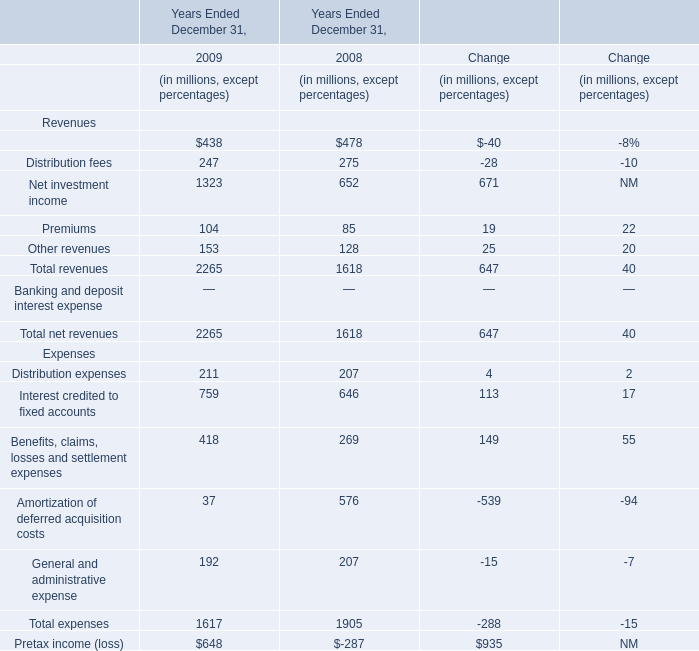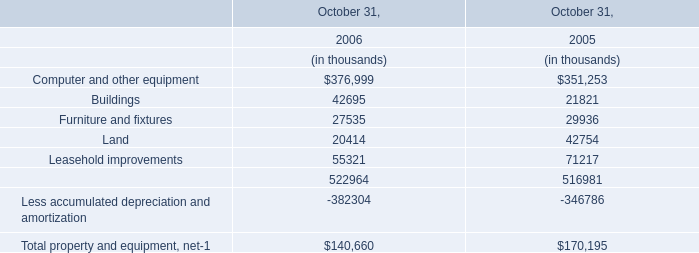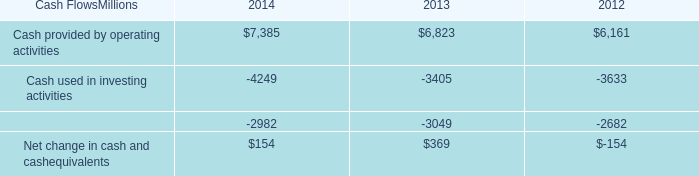What will Interest credited to fixed accounts reach in 2010 if it continues to grow at its current rate? (in millions) 
Computations: ((((759 - 646) / 646) + 1) * 759)
Answer: 891.76625. 